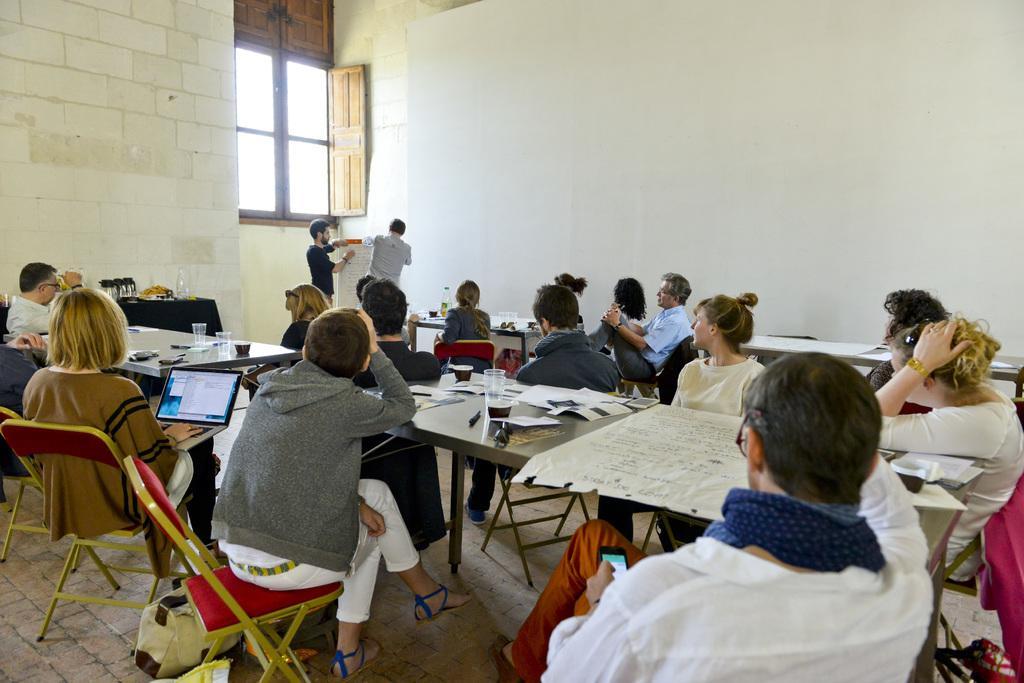Please provide a concise description of this image. This picture is clicked inside the room. In this picture, we see the people are sitting on the chairs. In front of them, we see the tables on which glasses, water bottles, charts and some other objects are placed. The woman on the left side is operating the laptop. On the left side, we see a table on which water bottle and some other objects are placed. In the background, we see two men are standing and they are holding the chart or a board. Behind them, we see a wall and a window. On the right side, we see the projector screen. 